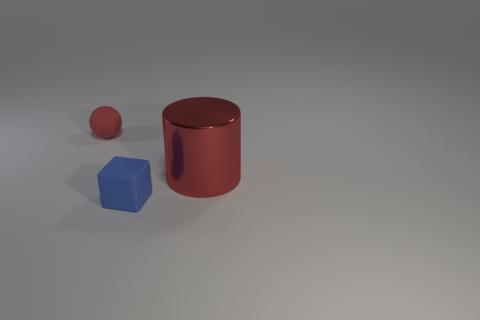Add 3 large red objects. How many objects exist? 6 Subtract all balls. How many objects are left? 2 Subtract all tiny blue matte things. Subtract all tiny cubes. How many objects are left? 1 Add 3 cubes. How many cubes are left? 4 Add 2 large red cubes. How many large red cubes exist? 2 Subtract 0 yellow blocks. How many objects are left? 3 